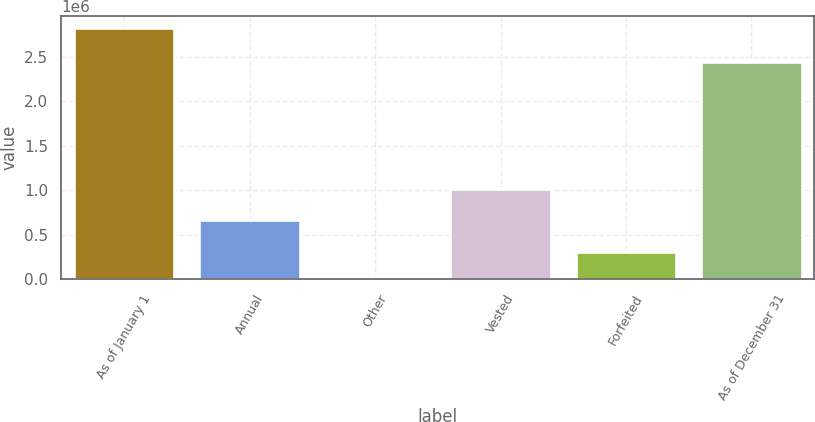Convert chart to OTSL. <chart><loc_0><loc_0><loc_500><loc_500><bar_chart><fcel>As of January 1<fcel>Annual<fcel>Other<fcel>Vested<fcel>Forfeited<fcel>As of December 31<nl><fcel>2.81779e+06<fcel>671204<fcel>26886<fcel>1.01061e+06<fcel>305976<fcel>2.44109e+06<nl></chart> 